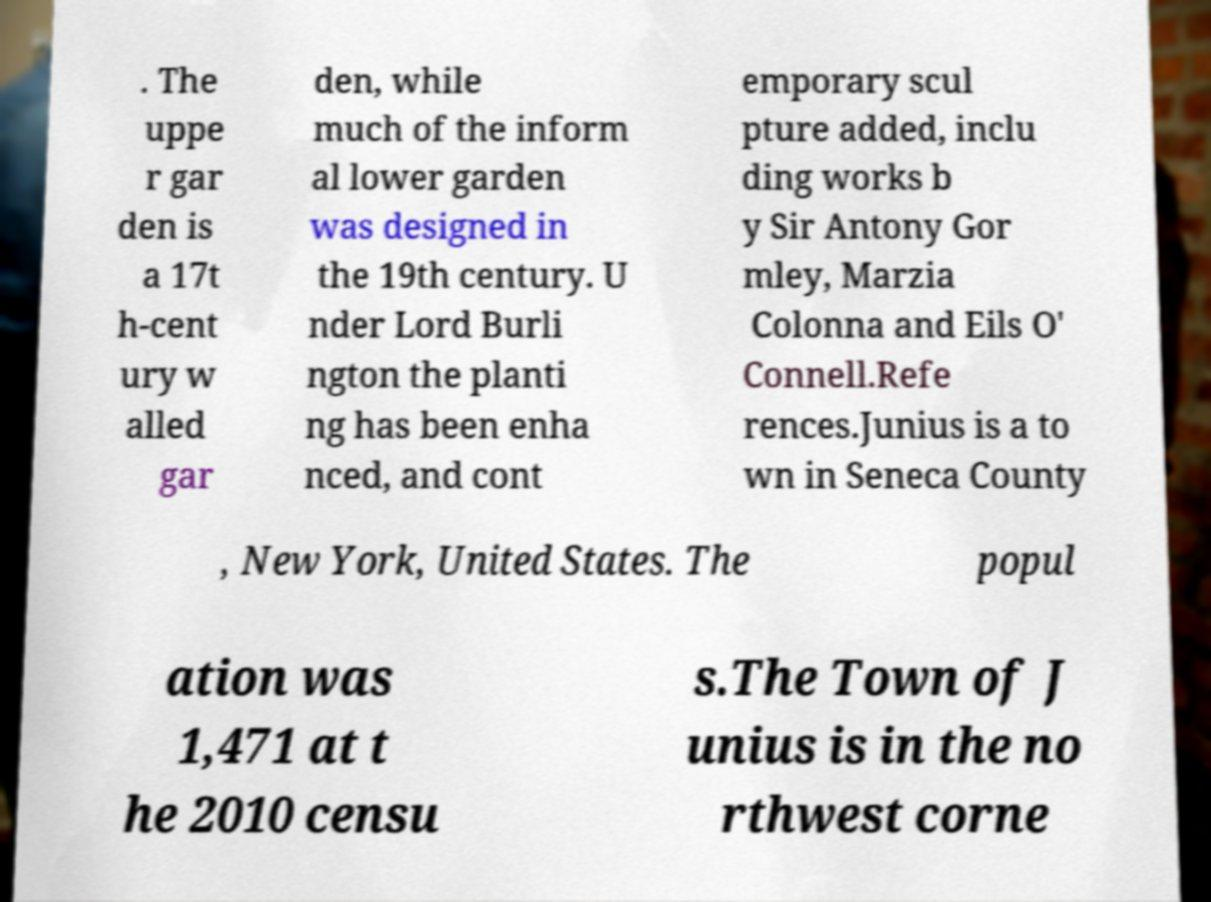What messages or text are displayed in this image? I need them in a readable, typed format. . The uppe r gar den is a 17t h-cent ury w alled gar den, while much of the inform al lower garden was designed in the 19th century. U nder Lord Burli ngton the planti ng has been enha nced, and cont emporary scul pture added, inclu ding works b y Sir Antony Gor mley, Marzia Colonna and Eils O' Connell.Refe rences.Junius is a to wn in Seneca County , New York, United States. The popul ation was 1,471 at t he 2010 censu s.The Town of J unius is in the no rthwest corne 